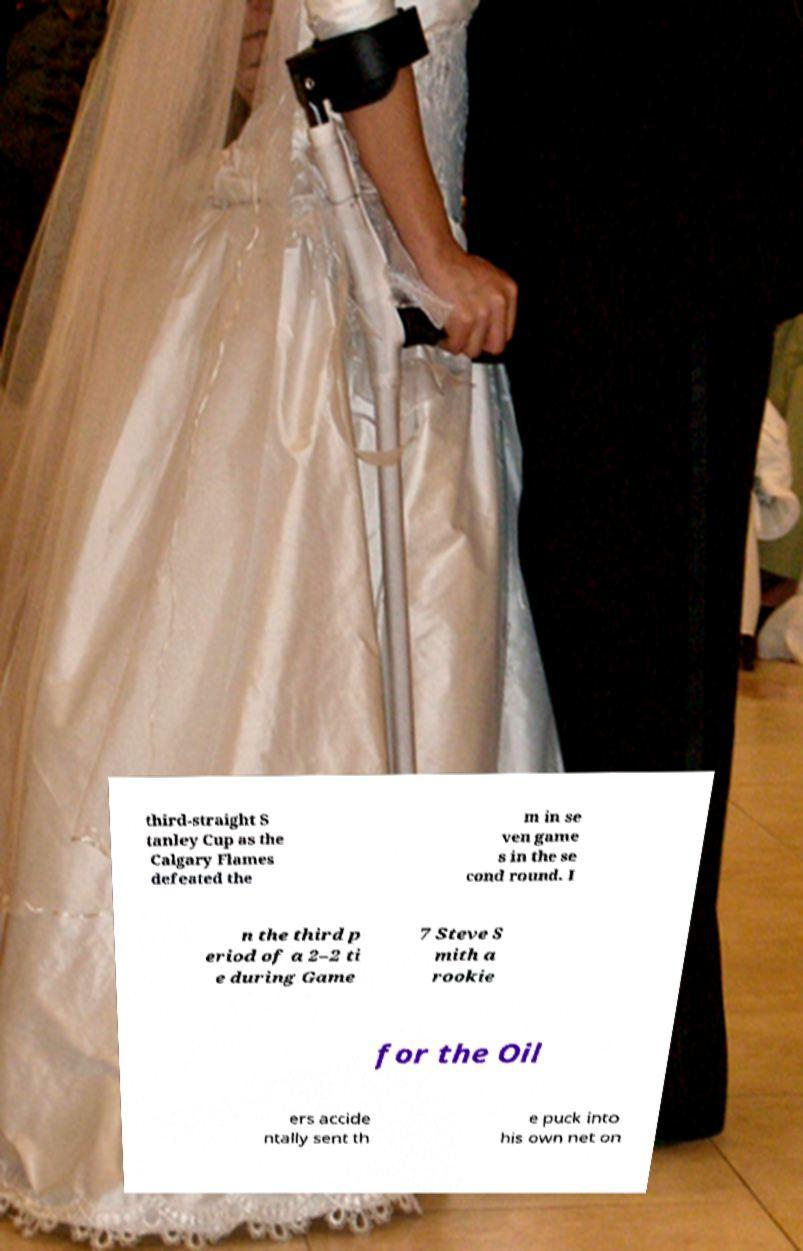What messages or text are displayed in this image? I need them in a readable, typed format. third-straight S tanley Cup as the Calgary Flames defeated the m in se ven game s in the se cond round. I n the third p eriod of a 2–2 ti e during Game 7 Steve S mith a rookie for the Oil ers accide ntally sent th e puck into his own net on 